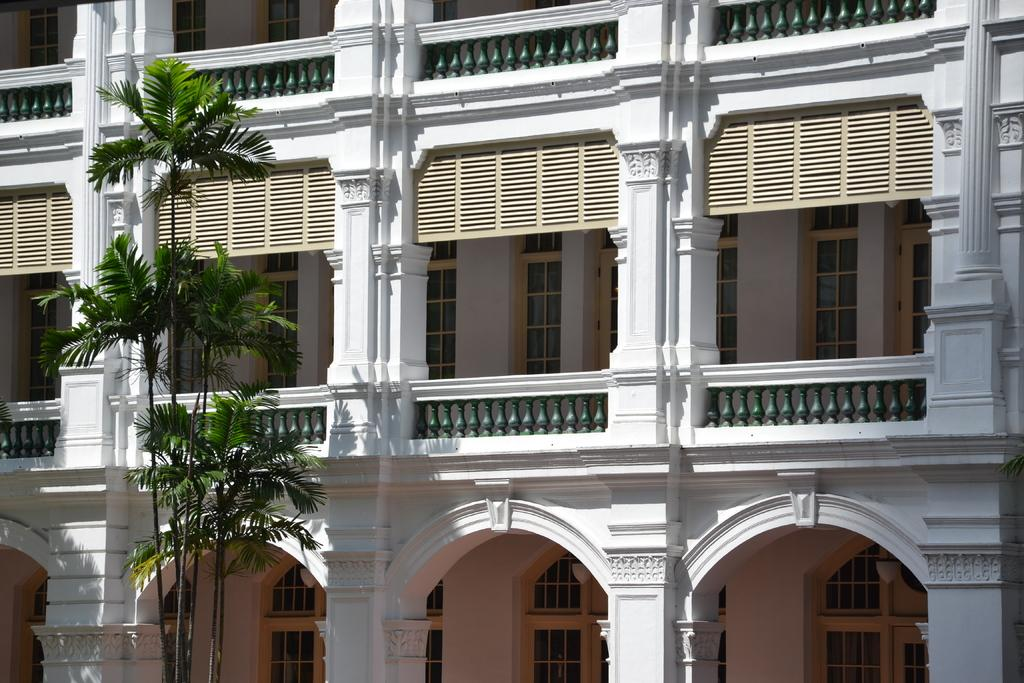What type of vegetation is in the foreground of the image? There are trees in the foreground of the image. What architectural features can be seen in the image? There are pillars, railing, windows, and arches in the image. How does the image provide comfort to the viewer? The image itself does not provide comfort to the viewer; it is a visual representation of trees and architectural features. Can you tell me how many times the person in the image sneezes? There is no person present in the image, so it is impossible to determine how many times they sneeze. 